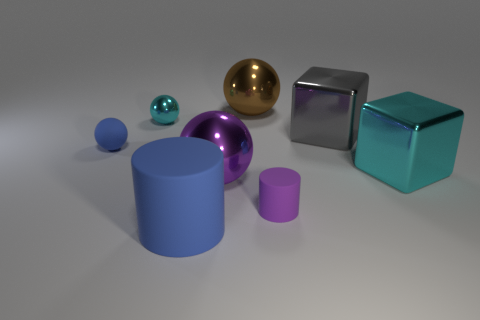What number of objects have the same color as the small matte sphere?
Your answer should be compact. 1. What is the gray cube made of?
Provide a succinct answer. Metal. What number of other things are the same size as the purple cylinder?
Your answer should be very brief. 2. There is a cyan object to the left of the large rubber cylinder; how big is it?
Ensure brevity in your answer.  Small. What is the material of the blue object that is behind the cyan object that is on the right side of the matte thing in front of the tiny purple cylinder?
Offer a very short reply. Rubber. Do the large gray object and the big matte object have the same shape?
Offer a terse response. No. What number of metal objects are either tiny yellow spheres or spheres?
Offer a terse response. 3. What number of large rubber cylinders are there?
Keep it short and to the point. 1. The other matte thing that is the same size as the purple matte thing is what color?
Provide a short and direct response. Blue. Do the gray thing and the cyan metallic sphere have the same size?
Keep it short and to the point. No. 